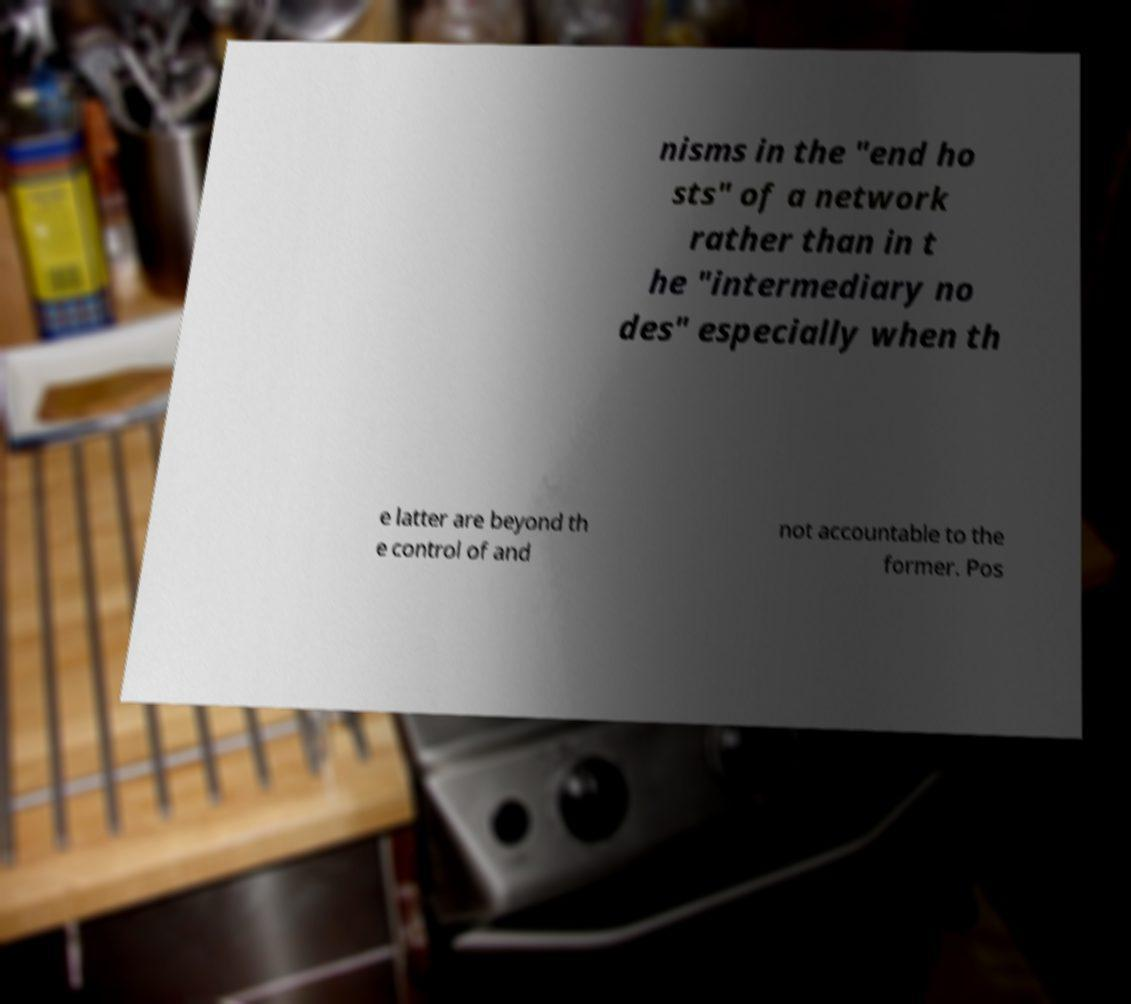I need the written content from this picture converted into text. Can you do that? nisms in the "end ho sts" of a network rather than in t he "intermediary no des" especially when th e latter are beyond th e control of and not accountable to the former. Pos 